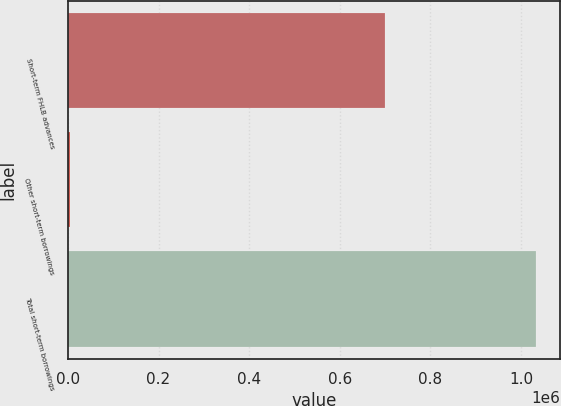Convert chart. <chart><loc_0><loc_0><loc_500><loc_500><bar_chart><fcel>Short-term FHLB advances<fcel>Other short-term borrowings<fcel>Total short-term borrowings<nl><fcel>700000<fcel>3730<fcel>1.03373e+06<nl></chart> 